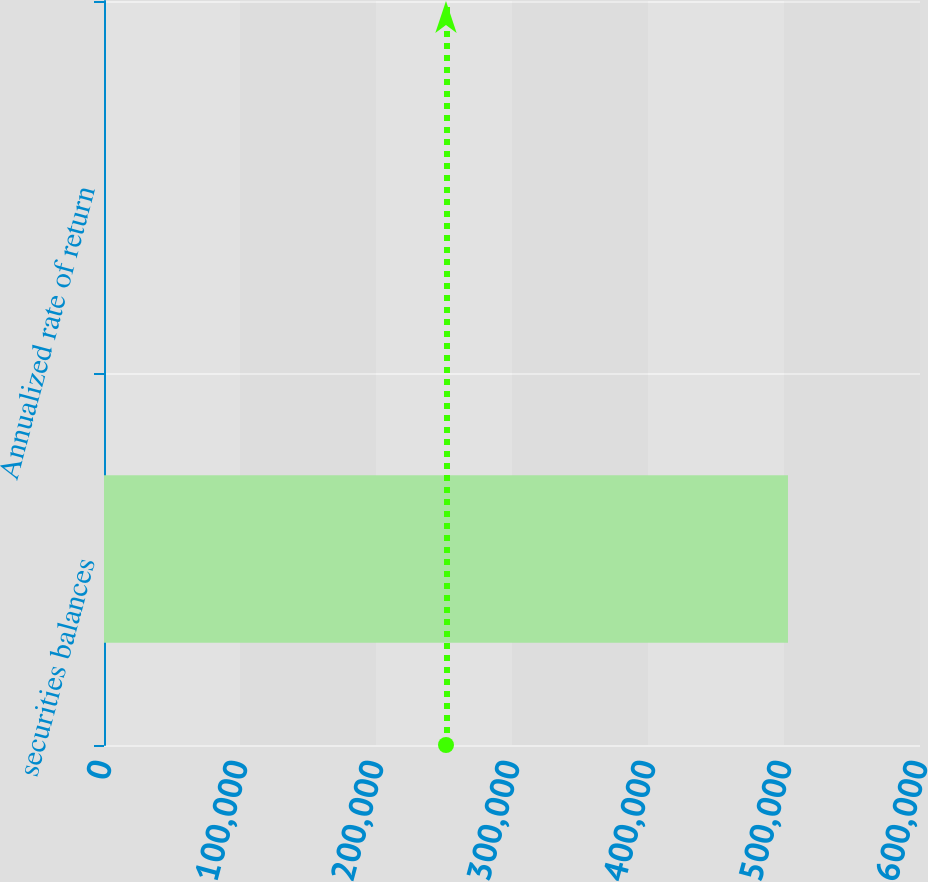Convert chart to OTSL. <chart><loc_0><loc_0><loc_500><loc_500><bar_chart><fcel>securities balances<fcel>Annualized rate of return<nl><fcel>502921<fcel>2.1<nl></chart> 